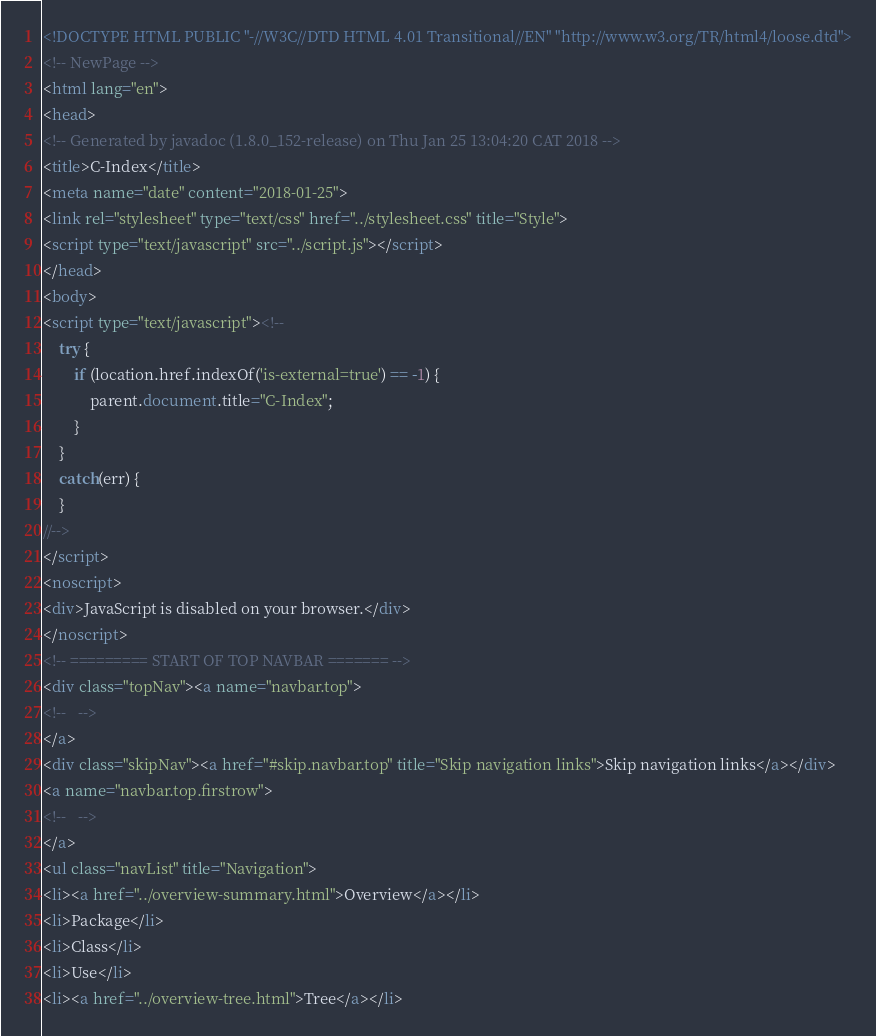<code> <loc_0><loc_0><loc_500><loc_500><_HTML_><!DOCTYPE HTML PUBLIC "-//W3C//DTD HTML 4.01 Transitional//EN" "http://www.w3.org/TR/html4/loose.dtd">
<!-- NewPage -->
<html lang="en">
<head>
<!-- Generated by javadoc (1.8.0_152-release) on Thu Jan 25 13:04:20 CAT 2018 -->
<title>C-Index</title>
<meta name="date" content="2018-01-25">
<link rel="stylesheet" type="text/css" href="../stylesheet.css" title="Style">
<script type="text/javascript" src="../script.js"></script>
</head>
<body>
<script type="text/javascript"><!--
    try {
        if (location.href.indexOf('is-external=true') == -1) {
            parent.document.title="C-Index";
        }
    }
    catch(err) {
    }
//-->
</script>
<noscript>
<div>JavaScript is disabled on your browser.</div>
</noscript>
<!-- ========= START OF TOP NAVBAR ======= -->
<div class="topNav"><a name="navbar.top">
<!--   -->
</a>
<div class="skipNav"><a href="#skip.navbar.top" title="Skip navigation links">Skip navigation links</a></div>
<a name="navbar.top.firstrow">
<!--   -->
</a>
<ul class="navList" title="Navigation">
<li><a href="../overview-summary.html">Overview</a></li>
<li>Package</li>
<li>Class</li>
<li>Use</li>
<li><a href="../overview-tree.html">Tree</a></li></code> 